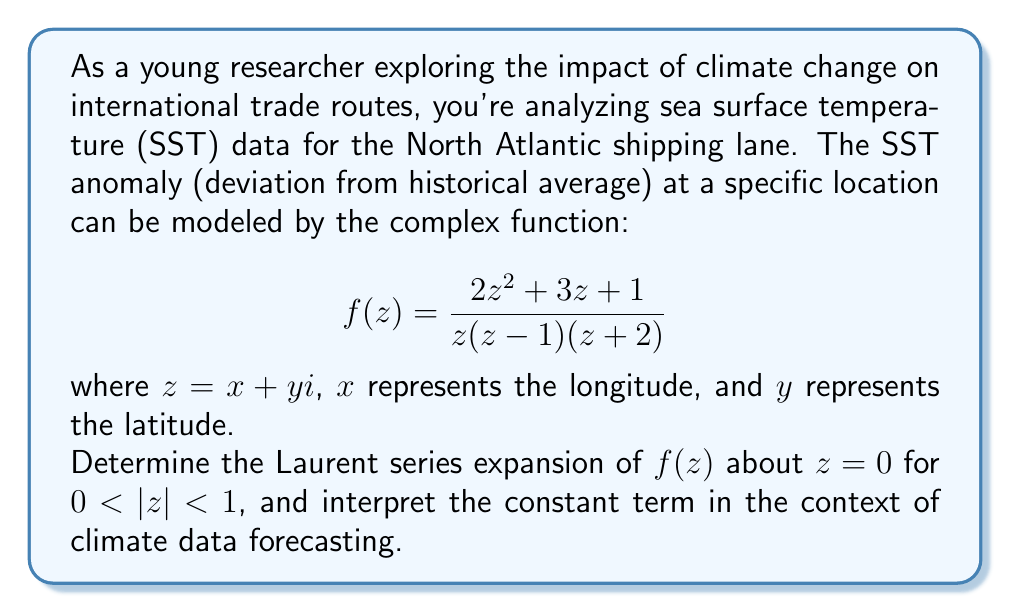Provide a solution to this math problem. To find the Laurent series expansion of $f(z)$ about $z=0$ for $0 < |z| < 1$, we follow these steps:

1) First, we partial fraction decompose $f(z)$:

   $$f(z) = \frac{2z^2 + 3z + 1}{z(z-1)(z+2)} = \frac{A}{z} + \frac{B}{z-1} + \frac{C}{z+2}$$

2) Solving for A, B, and C:
   
   $A = \lim_{z \to 0} zf(z) = 1$
   $B = \lim_{z \to 1} (z-1)f(z) = -4$
   $C = \lim_{z \to -2} (z+2)f(z) = 3$

3) So, we have:

   $$f(z) = \frac{1}{z} - \frac{4}{z-1} + \frac{3}{z+2}$$

4) For $0 < |z| < 1$, we can expand each term:

   $\frac{1}{z}$ is already in the correct form.

   $-\frac{4}{z-1} = -4(-\frac{1}{1-z}) = 4\sum_{n=0}^{\infty} z^n$

   $\frac{3}{z+2} = \frac{3}{2}\frac{1}{1+\frac{z}{2}} = \frac{3}{2}\sum_{n=0}^{\infty} (-\frac{z}{2})^n$

5) Combining these:

   $$f(z) = \frac{1}{z} + 4\sum_{n=0}^{\infty} z^n + \frac{3}{2}\sum_{n=0}^{\infty} (-\frac{z}{2})^n$$

6) The constant term (n=0) in this expansion is:

   $$4 + \frac{3}{2} = \frac{11}{2} = 5.5$$

Interpretation: In the context of climate data forecasting, the constant term (5.5°C) represents the baseline SST anomaly at the origin (0,0) of our coordinate system. This suggests a significant warming trend in this part of the North Atlantic, which could have substantial implications for shipping routes, such as the potential opening of new paths or the need for vessels to adapt to warmer waters.
Answer: $$f(z) = \frac{1}{z} + 4\sum_{n=0}^{\infty} z^n + \frac{3}{2}\sum_{n=0}^{\infty} (-\frac{z}{2})^n$$
Constant term: 5.5°C 